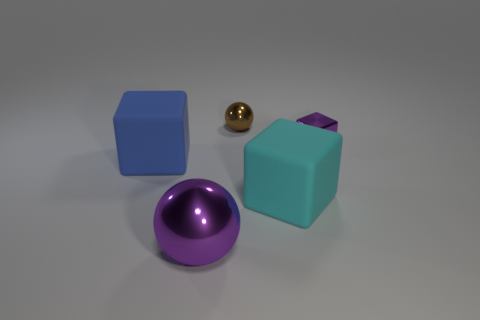Subtract all small metallic blocks. How many blocks are left? 2 Add 4 cyan rubber things. How many objects exist? 9 Subtract all yellow blocks. Subtract all yellow spheres. How many blocks are left? 3 Subtract all spheres. How many objects are left? 3 Subtract all large blue cubes. Subtract all matte objects. How many objects are left? 2 Add 4 cyan rubber objects. How many cyan rubber objects are left? 5 Add 1 small matte balls. How many small matte balls exist? 1 Subtract 0 brown blocks. How many objects are left? 5 